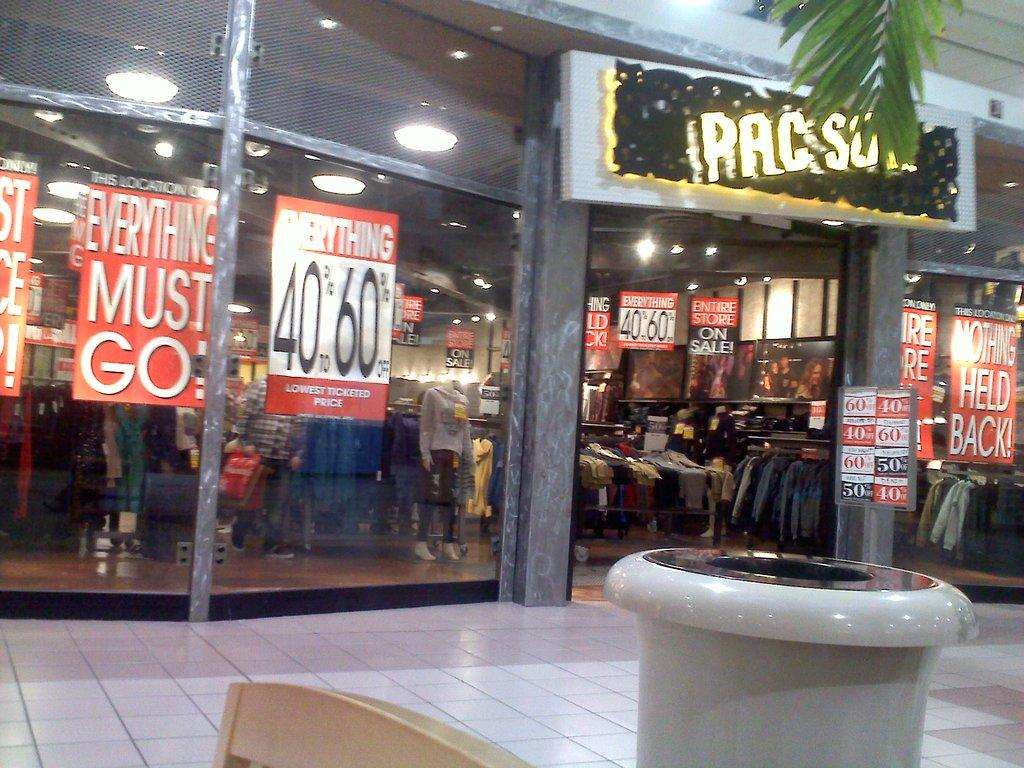What type of establishment is shown in the image? There is a store in the image. What kind of products can be found in the store? The store contains clothes. Can you describe a feature of the store's exterior? There is a name board with lights on the right side of the store. What can be seen in the background of the image? Green leaves are visible at the top of the image. How does the boat navigate through the clothes in the store? There is no boat present in the image; the store contains clothes. 